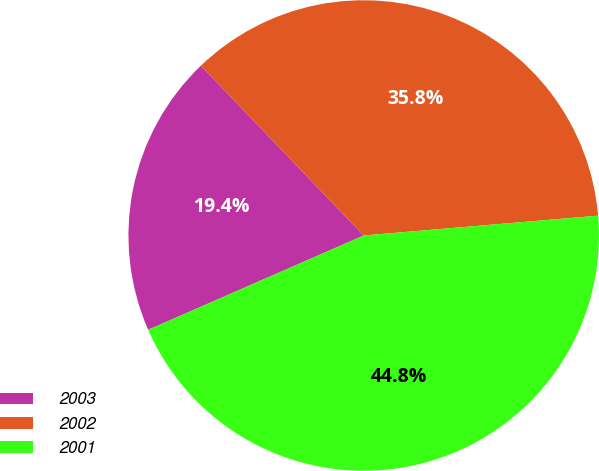<chart> <loc_0><loc_0><loc_500><loc_500><pie_chart><fcel>2003<fcel>2002<fcel>2001<nl><fcel>19.4%<fcel>35.82%<fcel>44.78%<nl></chart> 